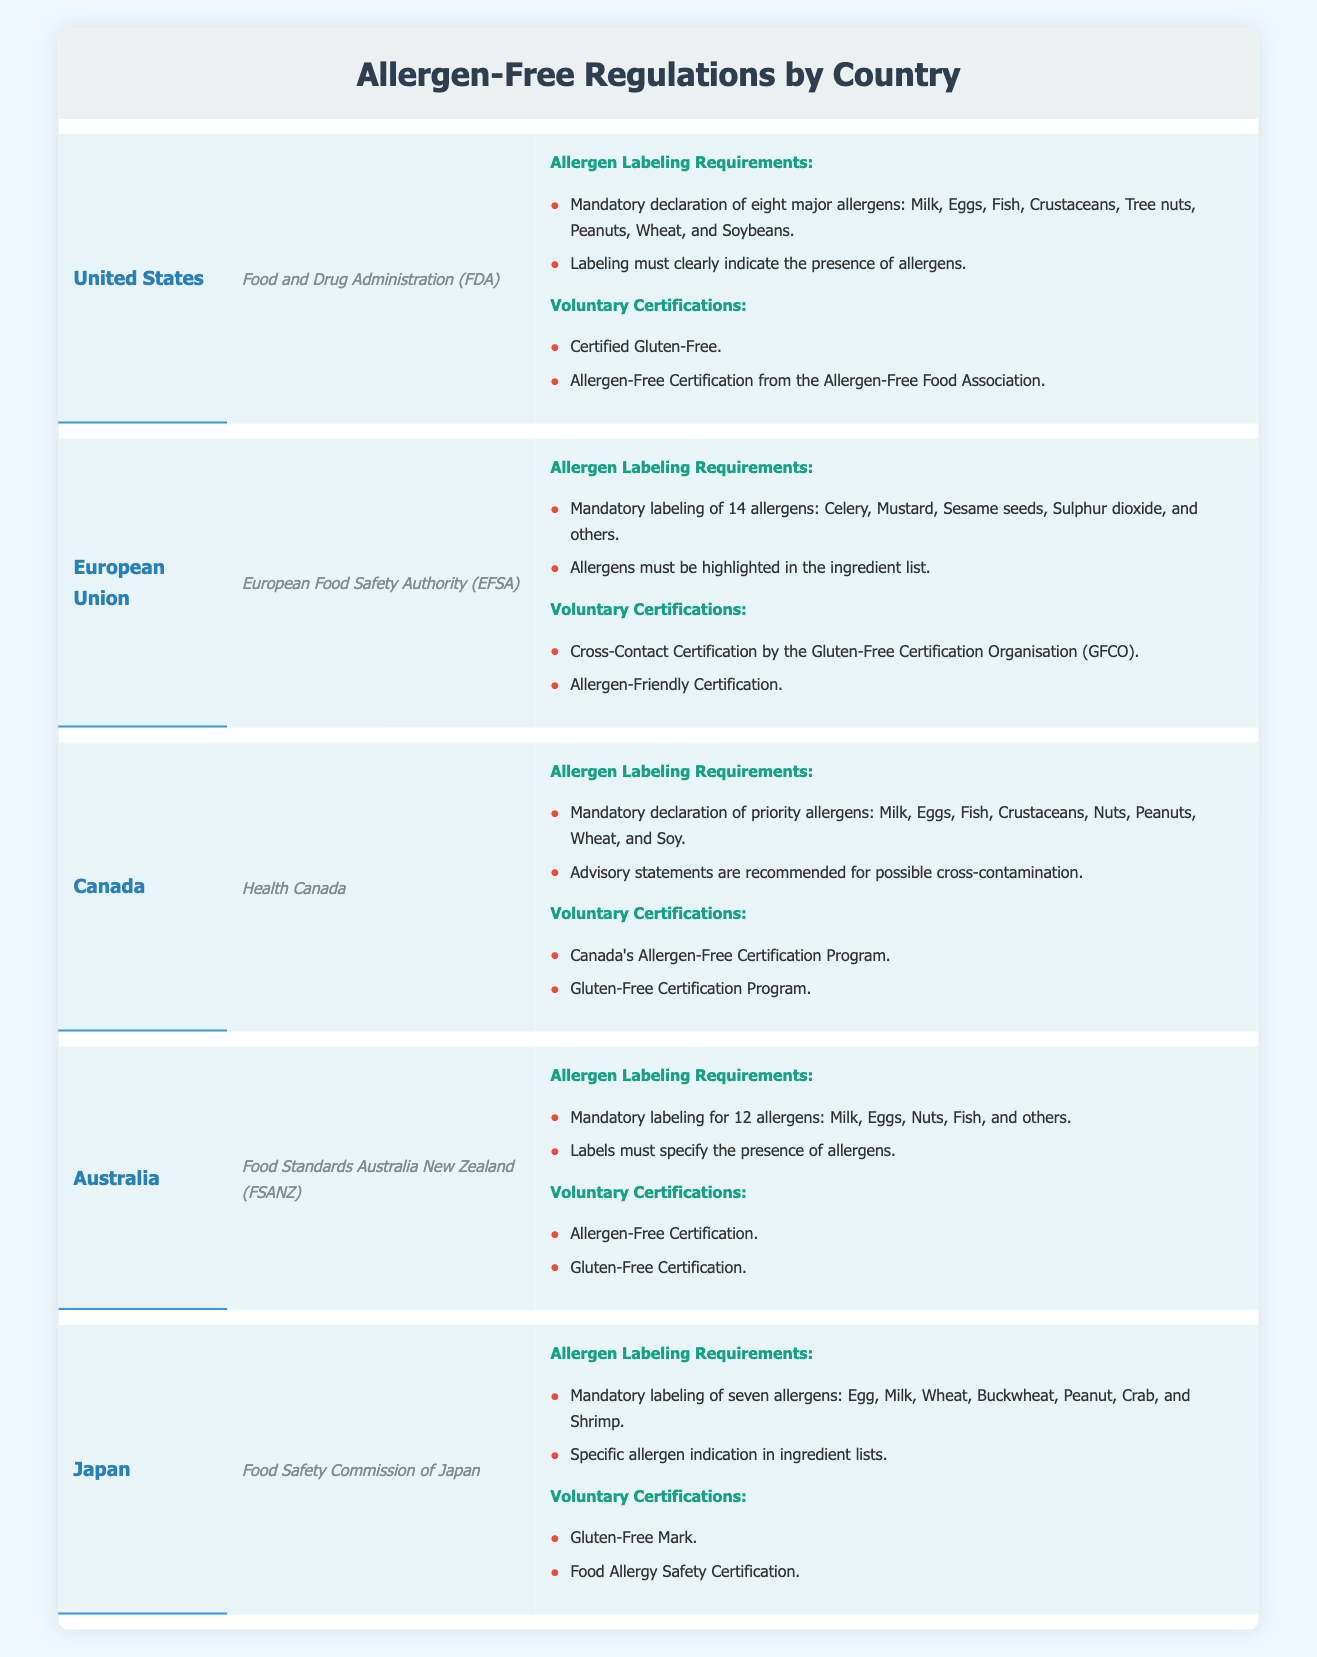What agency oversees allergen labeling in Canada? The table indicates that allergen labeling in Canada is overseen by Health Canada. This information is directly stated in the row corresponding to Canada in the table.
Answer: Health Canada How many allergens are mandatory to label in the European Union? The table shows that the mandatory labeling in the European Union includes 14 allergens. This is listed in the allergen labeling requirements section for the EU.
Answer: 14 Does Japan require labeling for crab as an allergen? According to the table, Japan has mandatory labeling for seven allergens, including crab. This is specifically stated in the allergen labeling requirements for Japan.
Answer: Yes What are the two voluntary certifications available in the United States? The table lists two voluntary certifications available in the United States: "Certified Gluten-Free" and "Allergen-Free Certification from the Allergen-Free Food Association." This information is included in the voluntary certifications section for the US.
Answer: Certified Gluten-Free and Allergen-Free Certification Which country requires advisory statements for possible cross-contamination? The table indicates that Canada recommends advisory statements for possible cross-contamination in their allergen labeling requirements. This is found in the Canada row, under allergen labeling requirements.
Answer: Canada What is the total number of allergens mandatory to label in Australia and Japan combined? Australia mandates labeling for 12 allergens and Japan for 7 allergens. To find the total, sum these two numbers: 12 + 7 = 19. Thus, the total number of mandatory allergens for both countries is 19.
Answer: 19 Is gluten-free certification mentioned in all countries listed? By reviewing the table, gluten-free certification is mentioned in the voluntary certifications section for the United States, Canada, Australia, and Japan, but not for the European Union. Therefore, the answer is no.
Answer: No Which country has the most allergens listed in its mandatory labeling requirements? The table shows that the European Union has 14 allergens listed as mandatory, while other countries have fewer: the United States has 8, Canada has 8, Australia has 12, and Japan has 7. Thus, the EU has the most allergens.
Answer: European Union What is one example of a voluntary certification offered by Australia? The table specifies that Australia offers "Allergen-Free Certification" as one of its voluntary certifications. This is found under the voluntary certifications section for Australia.
Answer: Allergen-Free Certification 